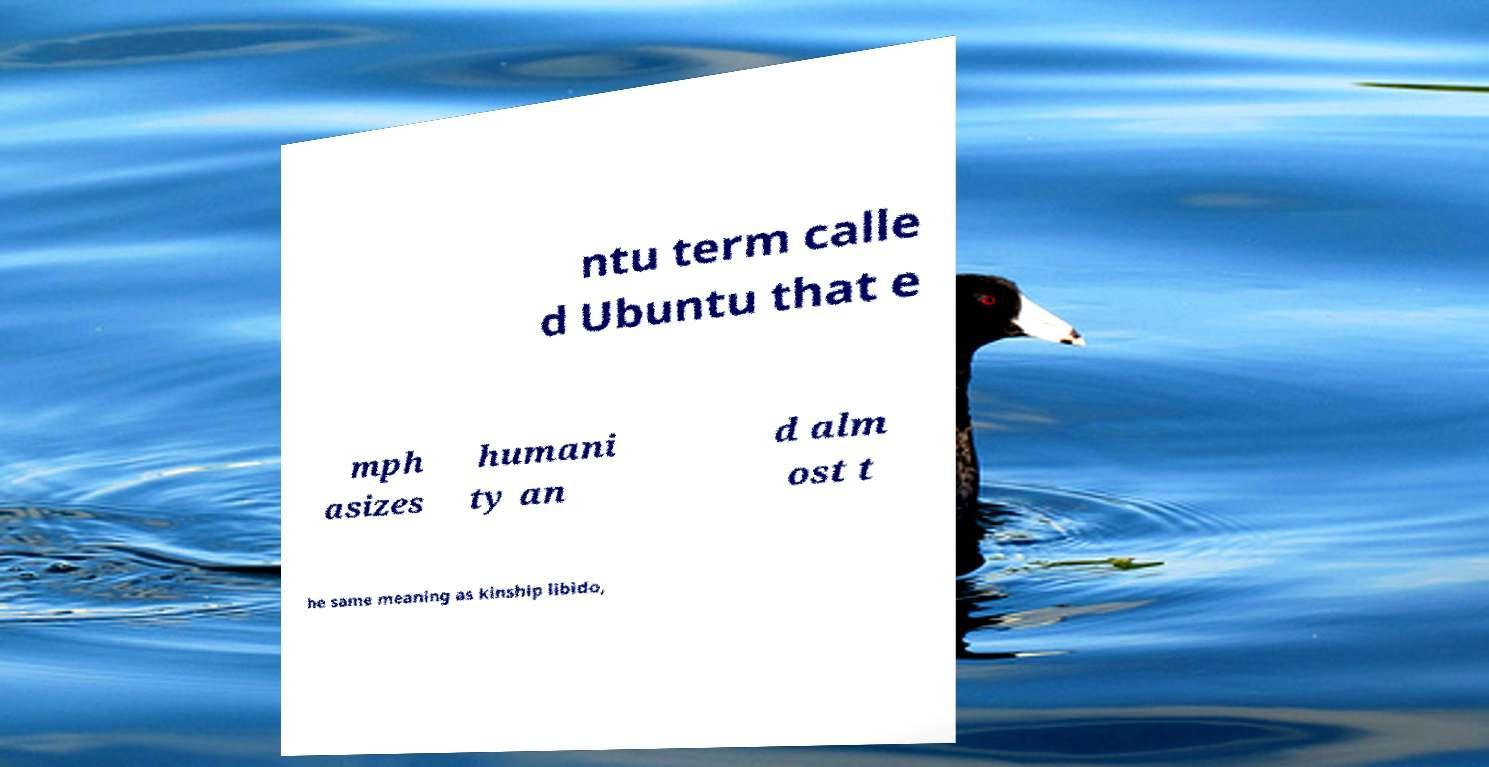Can you read and provide the text displayed in the image?This photo seems to have some interesting text. Can you extract and type it out for me? ntu term calle d Ubuntu that e mph asizes humani ty an d alm ost t he same meaning as kinship libido, 